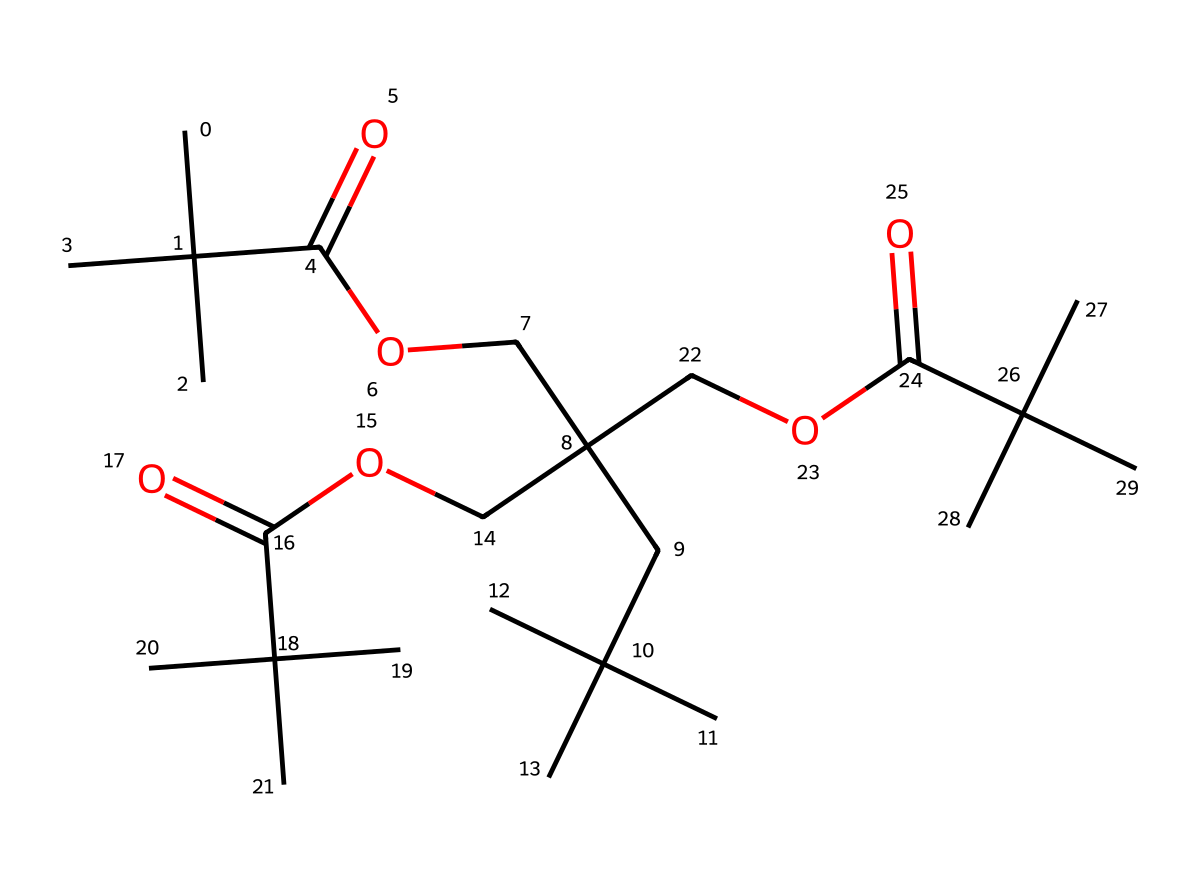what is the molecular formula of this compound? To determine the molecular formula, we need to count the number of carbon (C), hydrogen (H), and oxygen (O) atoms in the chemical structure. The structure contains 27 carbon atoms, 54 hydrogen atoms, and 6 oxygen atoms. Therefore, the molecular formula is C27H54O6.
Answer: C27H54O6 how many ester functional groups are present in the compound? An ester functional group is characterized by the presence of the functional group -COO-. By analyzing the structure, we see that there are four distinct ester linkages where the -COO- group is present.
Answer: four what is the predominant type of bonding in this compound? The predominant type of bonding in this compound is covalent bonding. The presence of multiple carbon and oxygen atoms connected by single and double bonds indicates that covalent bonds are forming between the atoms.
Answer: covalent describe the hydrophobic properties of this chemical based on its structure. The chemical contains long hydrocarbon chains (due to many carbon atoms in branched forms) and multiple ester groups, which contribute to its hydrophobic characteristics. The hydrophobic properties are primarily due to the large nonpolar hydrocarbon portions that do not interact favorably with water.
Answer: hydrophobic how might this compound perform in marine environments? Given the structure's extensive hydrophobic character and resistance to water, this compound is likely to form a protective coating that helps to prevent biofouling and corrosion in marine environments, making it ideal for marine equipment.
Answer: protective coating 